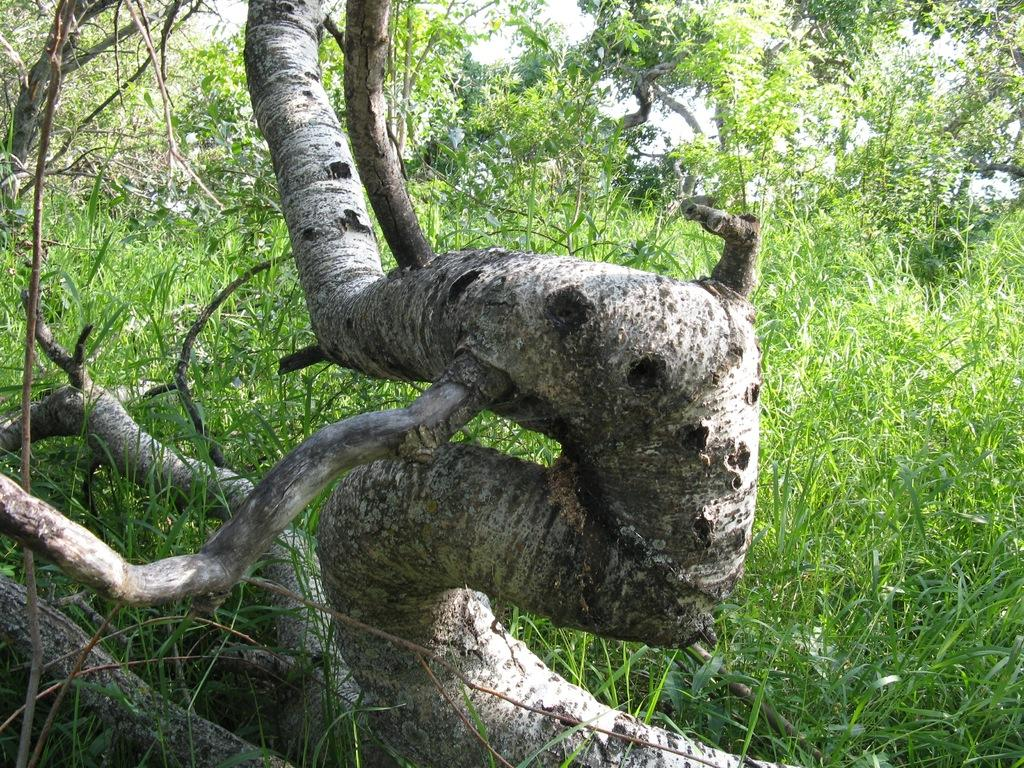What type of natural elements can be seen in the image? The image contains trees. Can you describe the tree trunk in the foreground of the image? There is a trunk of a tree in the foreground of the image. What type of yarn is being used by the governor to decorate the property in the image? There is no yarn, governor, or property present in the image. 